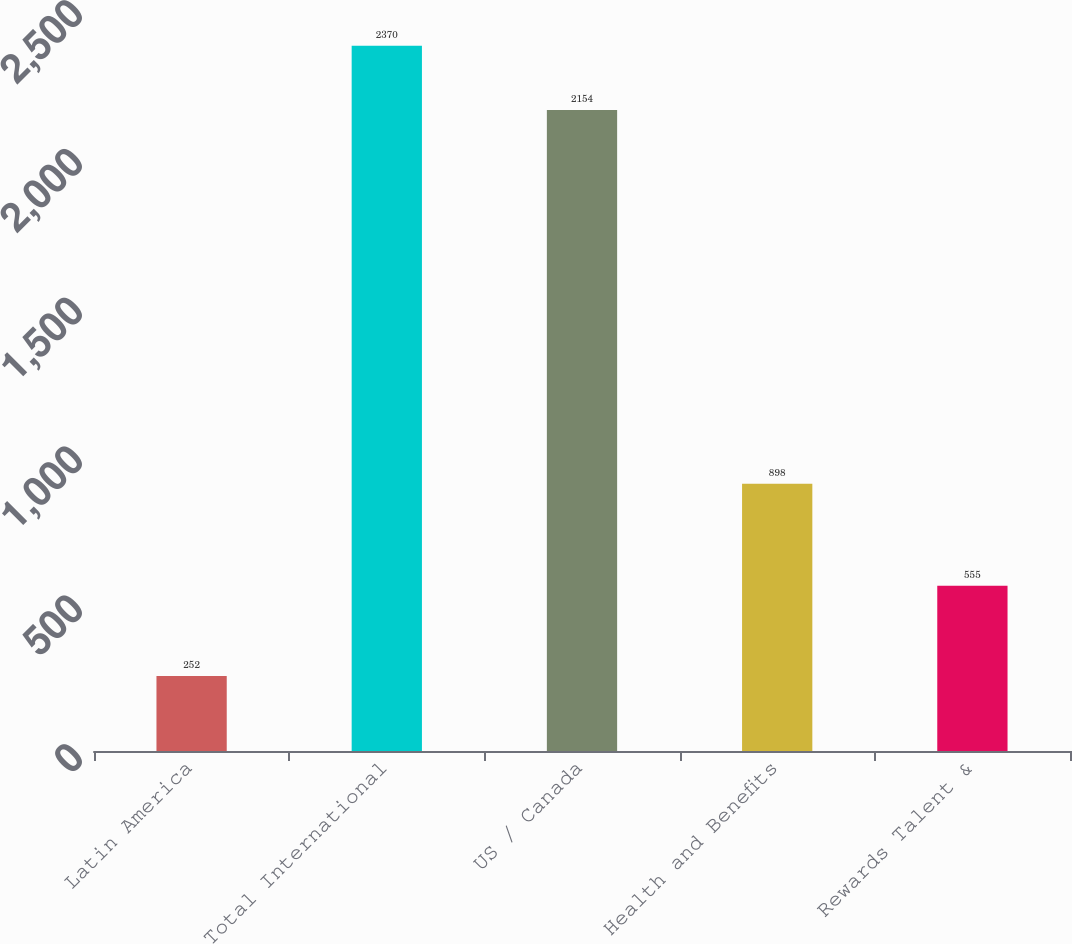Convert chart. <chart><loc_0><loc_0><loc_500><loc_500><bar_chart><fcel>Latin America<fcel>Total International<fcel>US / Canada<fcel>Health and Benefits<fcel>Rewards Talent &<nl><fcel>252<fcel>2370<fcel>2154<fcel>898<fcel>555<nl></chart> 